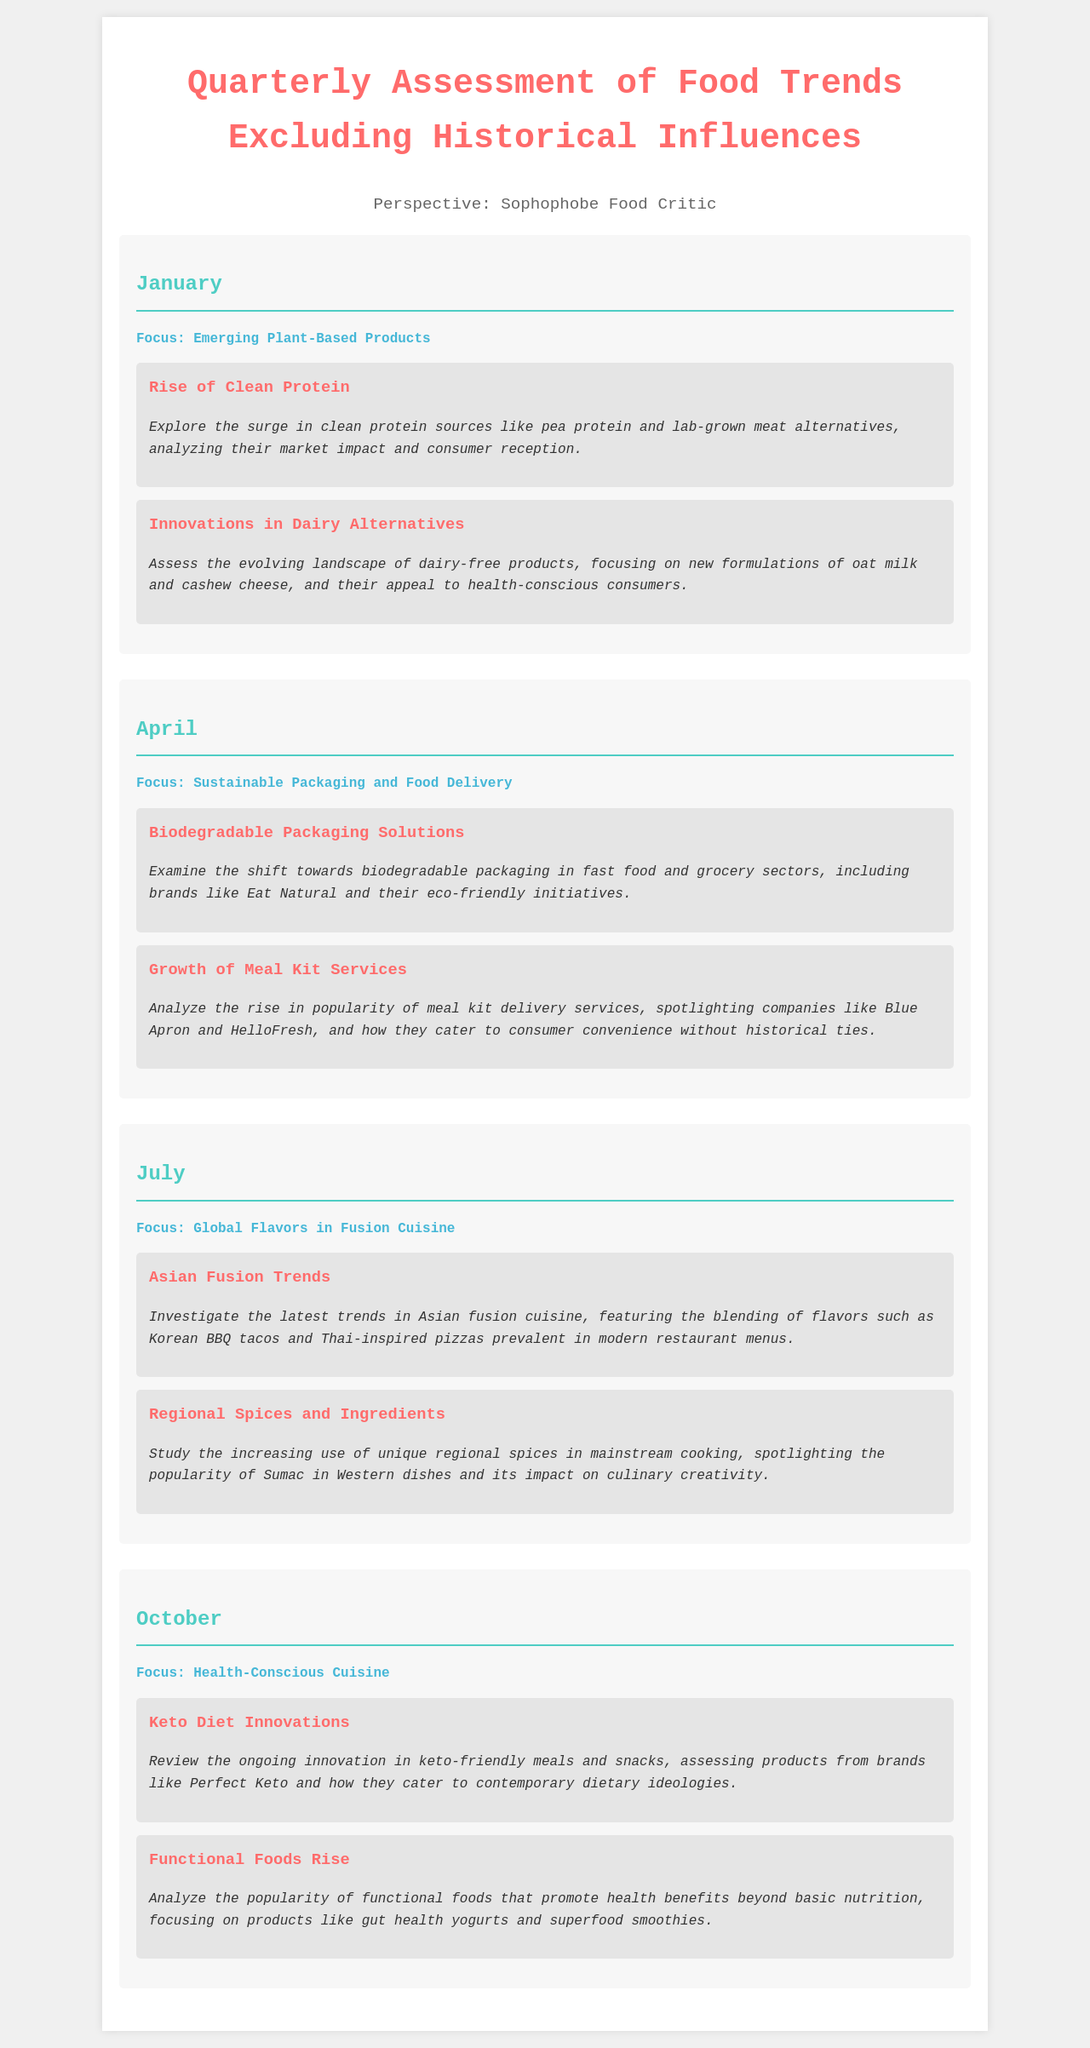What is the focus for January? The focus for January is about emerging plant-based products, exploring their market impact and consumer reception.
Answer: Emerging Plant-Based Products What trend is highlighted in April? April emphasizes sustainable packaging and food delivery, particularly focusing on environmental aspects and convenience in food service.
Answer: Sustainable Packaging and Food Delivery Which company is mentioned in relation to meal kit services? The document lists companies providing meal kit services that represent modern culinary convenience.
Answer: Blue Apron What flavor fusion is discussed in July? July discusses Asian fusion trends, detailing specific combinations of culinary influences in contemporary menus.
Answer: Asian Fusion Trends What kind of products are assessed in October? The products reviewed include innovative options catering to contemporary dietary trends and consumer preferences in health.
Answer: Keto Diet Innovations How many topics are covered in each quarter? Each quarter contains a specified number of topics detailing trends and innovations in food without historical influences.
Answer: 2 What is the main theme for October? The main theme for October relates to the growing focus on health and nutritious food options in modern diets.
Answer: Health-Conscious Cuisine Which ingredient's popularity is driven by regional cuisine mentioned in July? The document specifies a unique spice that is being increasingly used in mainstream cooking, signifying culinary creativity from various regions.
Answer: Sumac What is the aim of the quarterly assessment? The assessment aims to analyze current food trends while intentionally excluding any historical context or influences behind these trends.
Answer: Excluding Historical Influences 